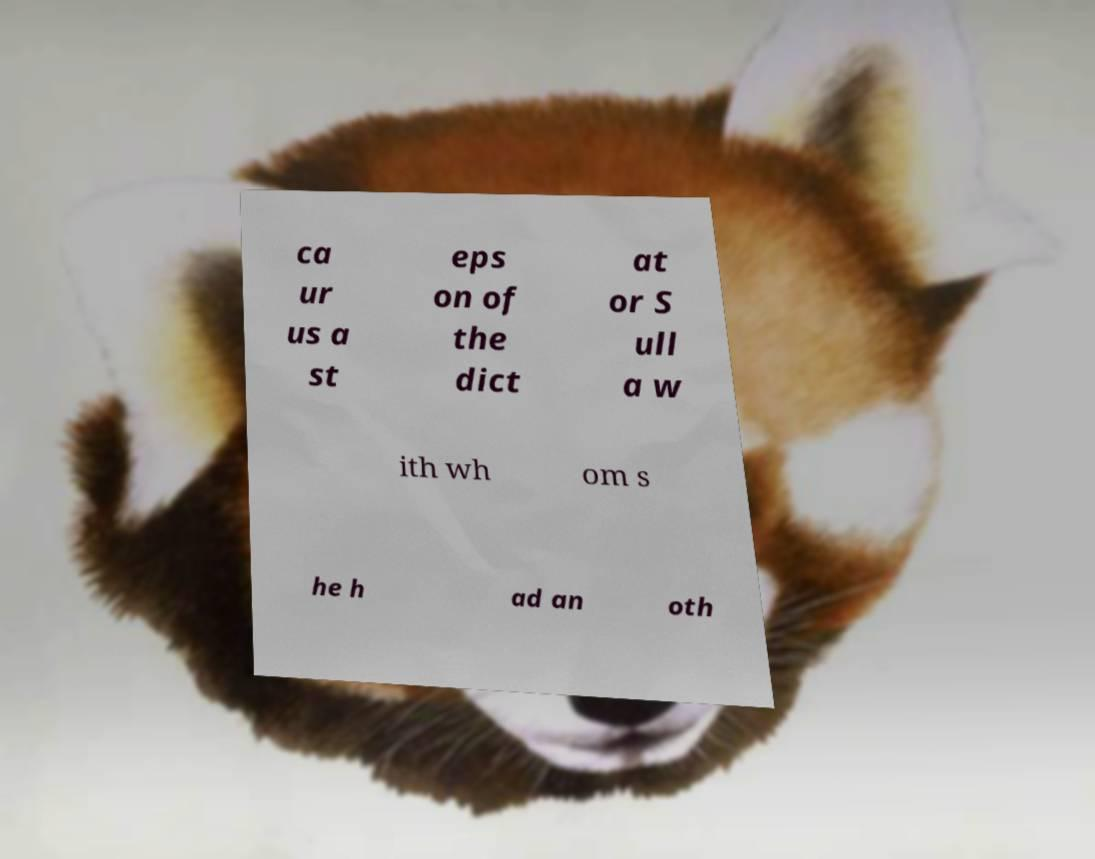Could you extract and type out the text from this image? ca ur us a st eps on of the dict at or S ull a w ith wh om s he h ad an oth 